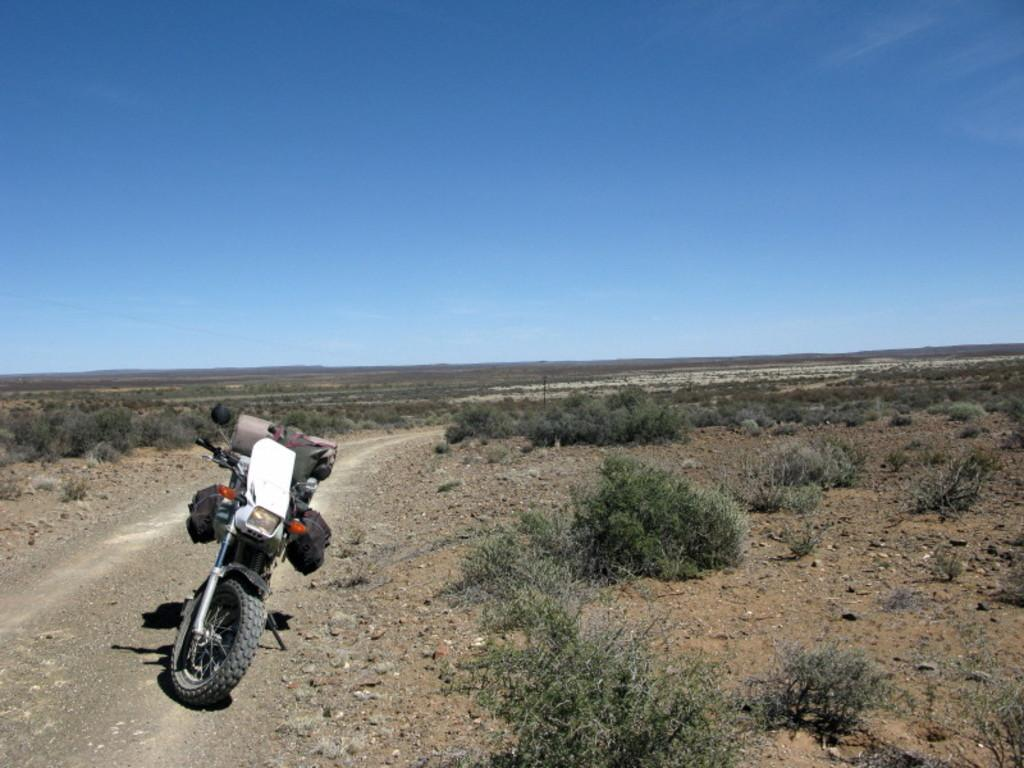What is the main object in the image? There is a bike in the image. What is attached to the bike? Bags are present on the bike. What type of surface is visible in the image? There is ground visible in the image. What type of vegetation is on the ground? Small plants are on the ground. What is visible at the top of the image? The sky is visible at the top of the image. What type of knife is being used to cut the ink in the image? There is no knife or ink present in the image; it features a bike with bags and a ground with small plants. 